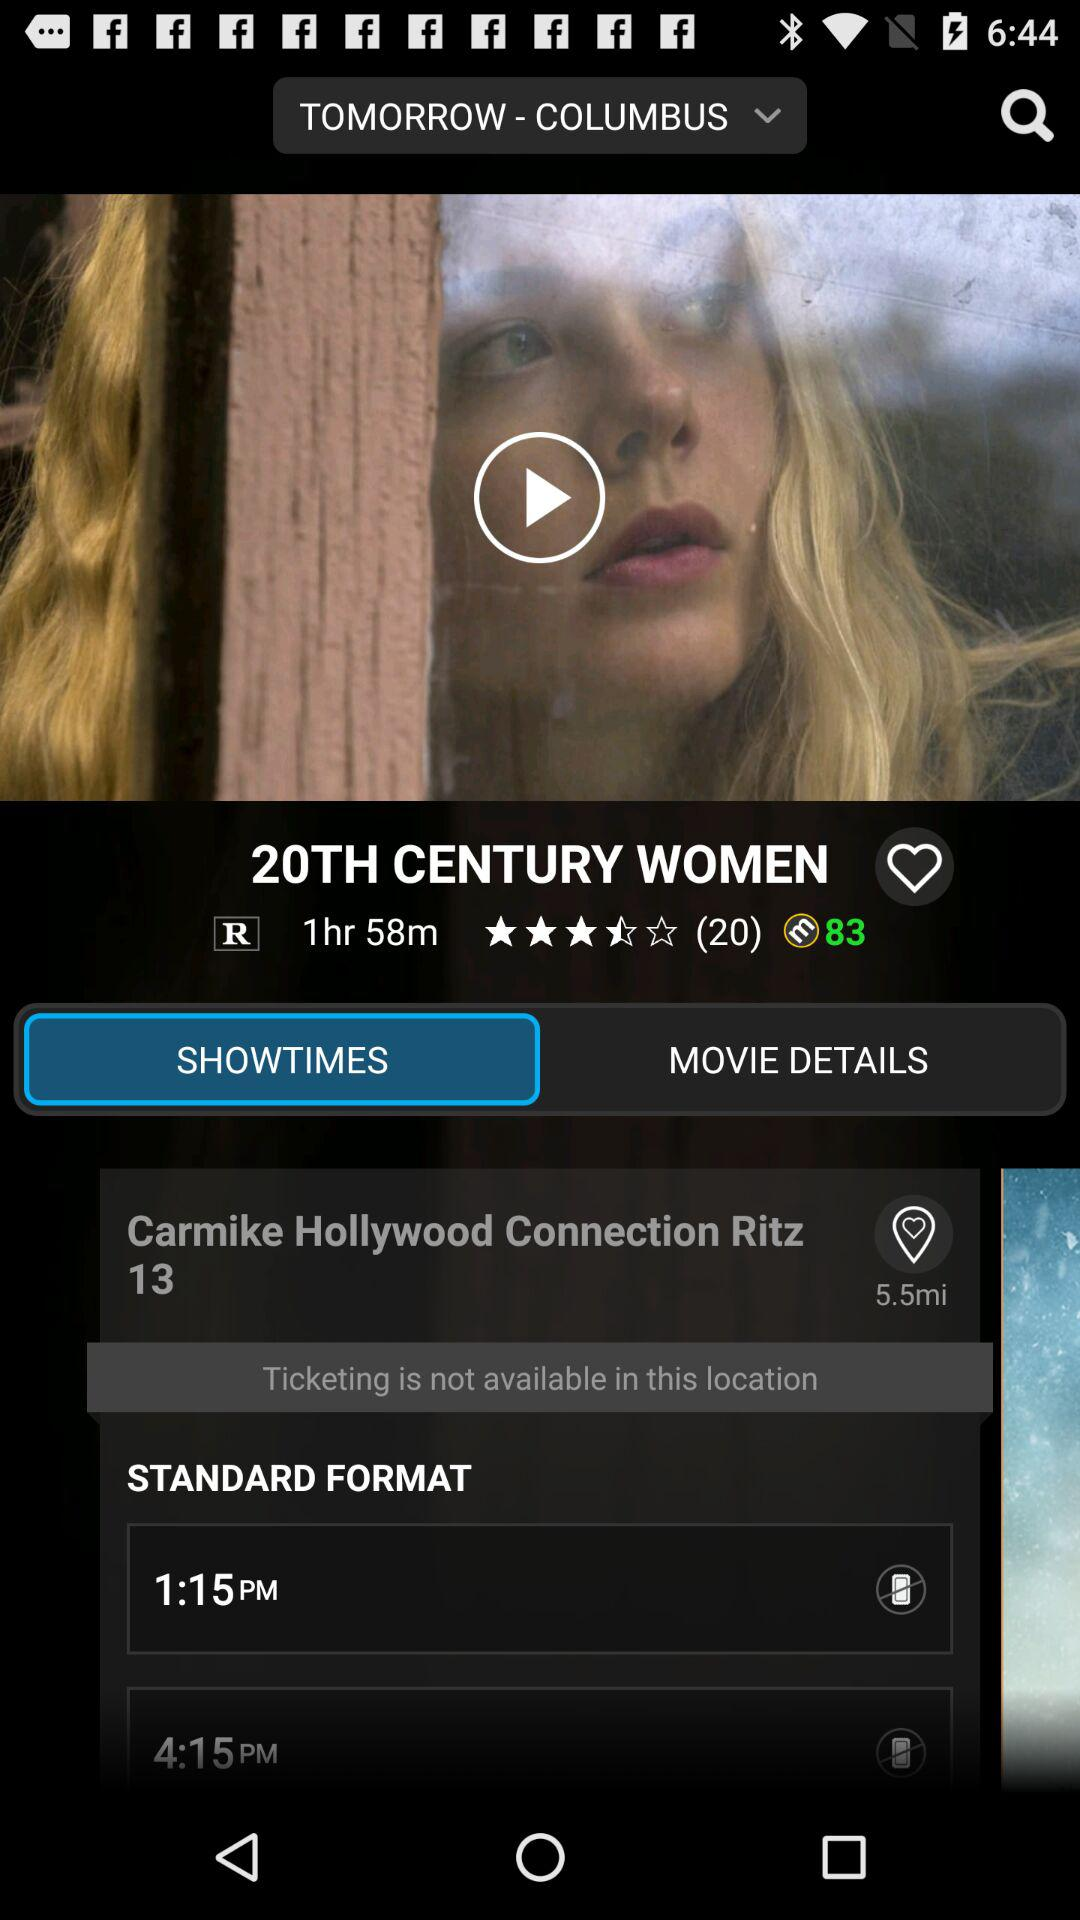Are tickets available in Carmike Hollywood Connection Ritz 13? The tickets are not available. 